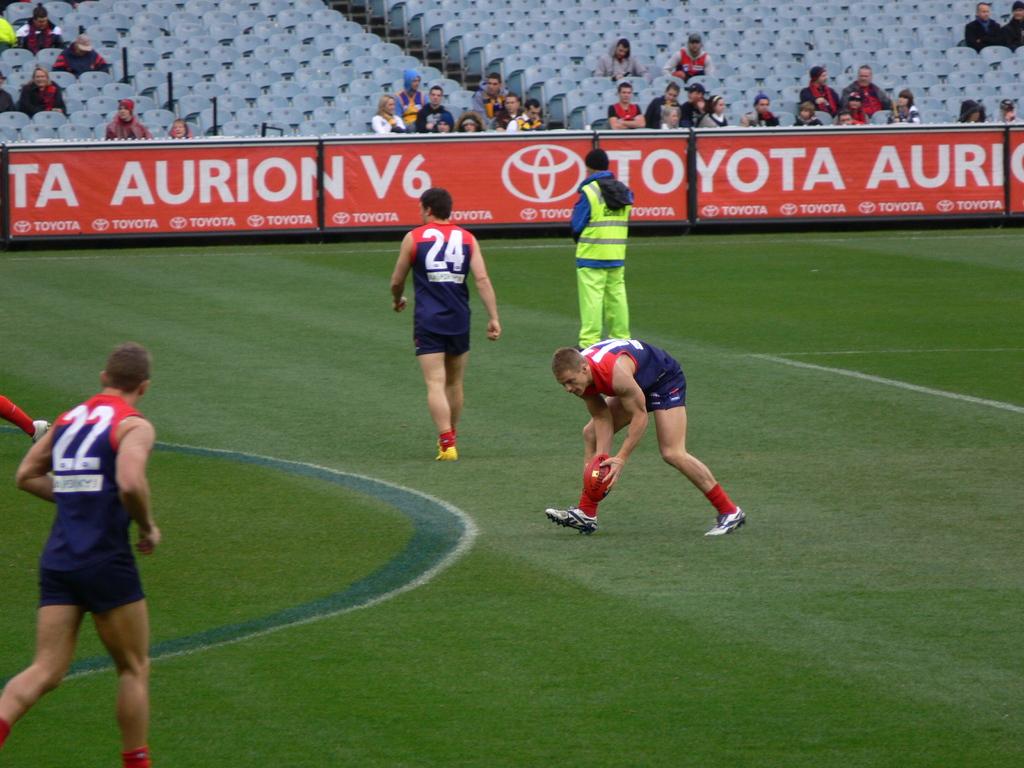Who is the sponsor of the game?
Your answer should be compact. Toyota. 